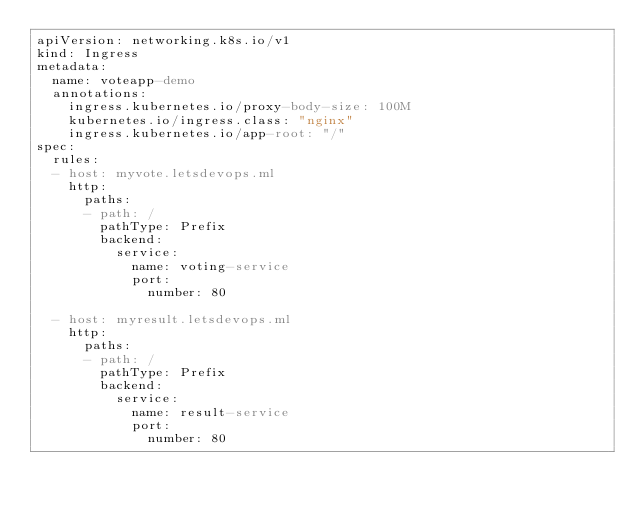<code> <loc_0><loc_0><loc_500><loc_500><_YAML_>apiVersion: networking.k8s.io/v1
kind: Ingress
metadata:
  name: voteapp-demo
  annotations:
    ingress.kubernetes.io/proxy-body-size: 100M
    kubernetes.io/ingress.class: "nginx"
    ingress.kubernetes.io/app-root: "/"
spec:
  rules:
  - host: myvote.letsdevops.ml
    http:
      paths:
      - path: /
        pathType: Prefix
        backend:
          service:
            name: voting-service
            port:
              number: 80

  - host: myresult.letsdevops.ml
    http:
      paths:
      - path: /
        pathType: Prefix
        backend:
          service:
            name: result-service
            port:
              number: 80</code> 